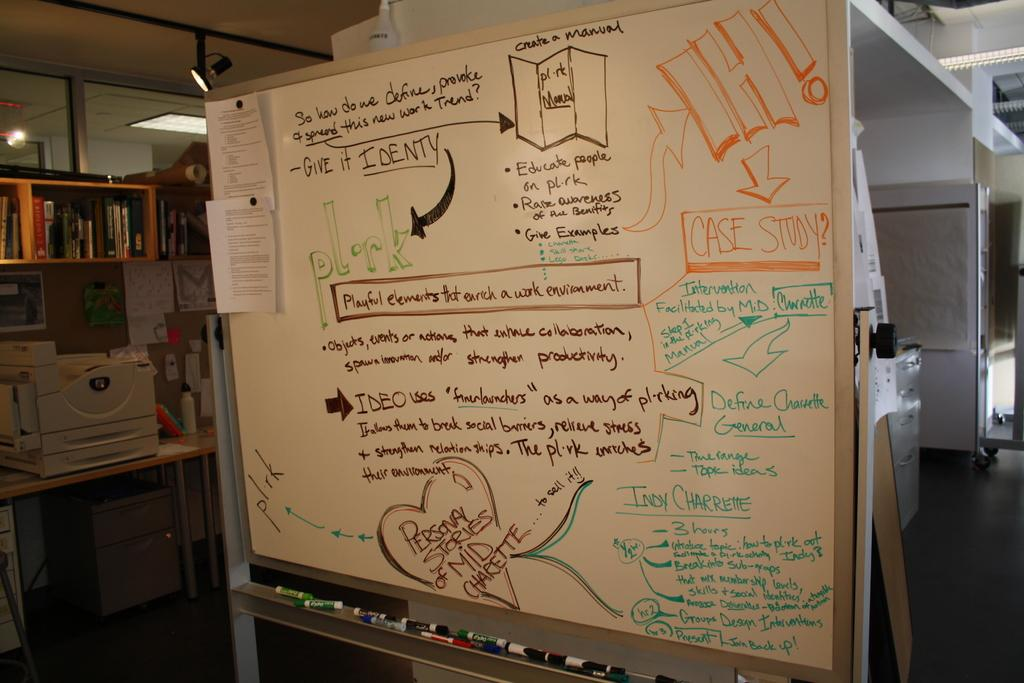<image>
Give a short and clear explanation of the subsequent image. A whiteboard which has the sentence 'Give it Identity' on the top left. 